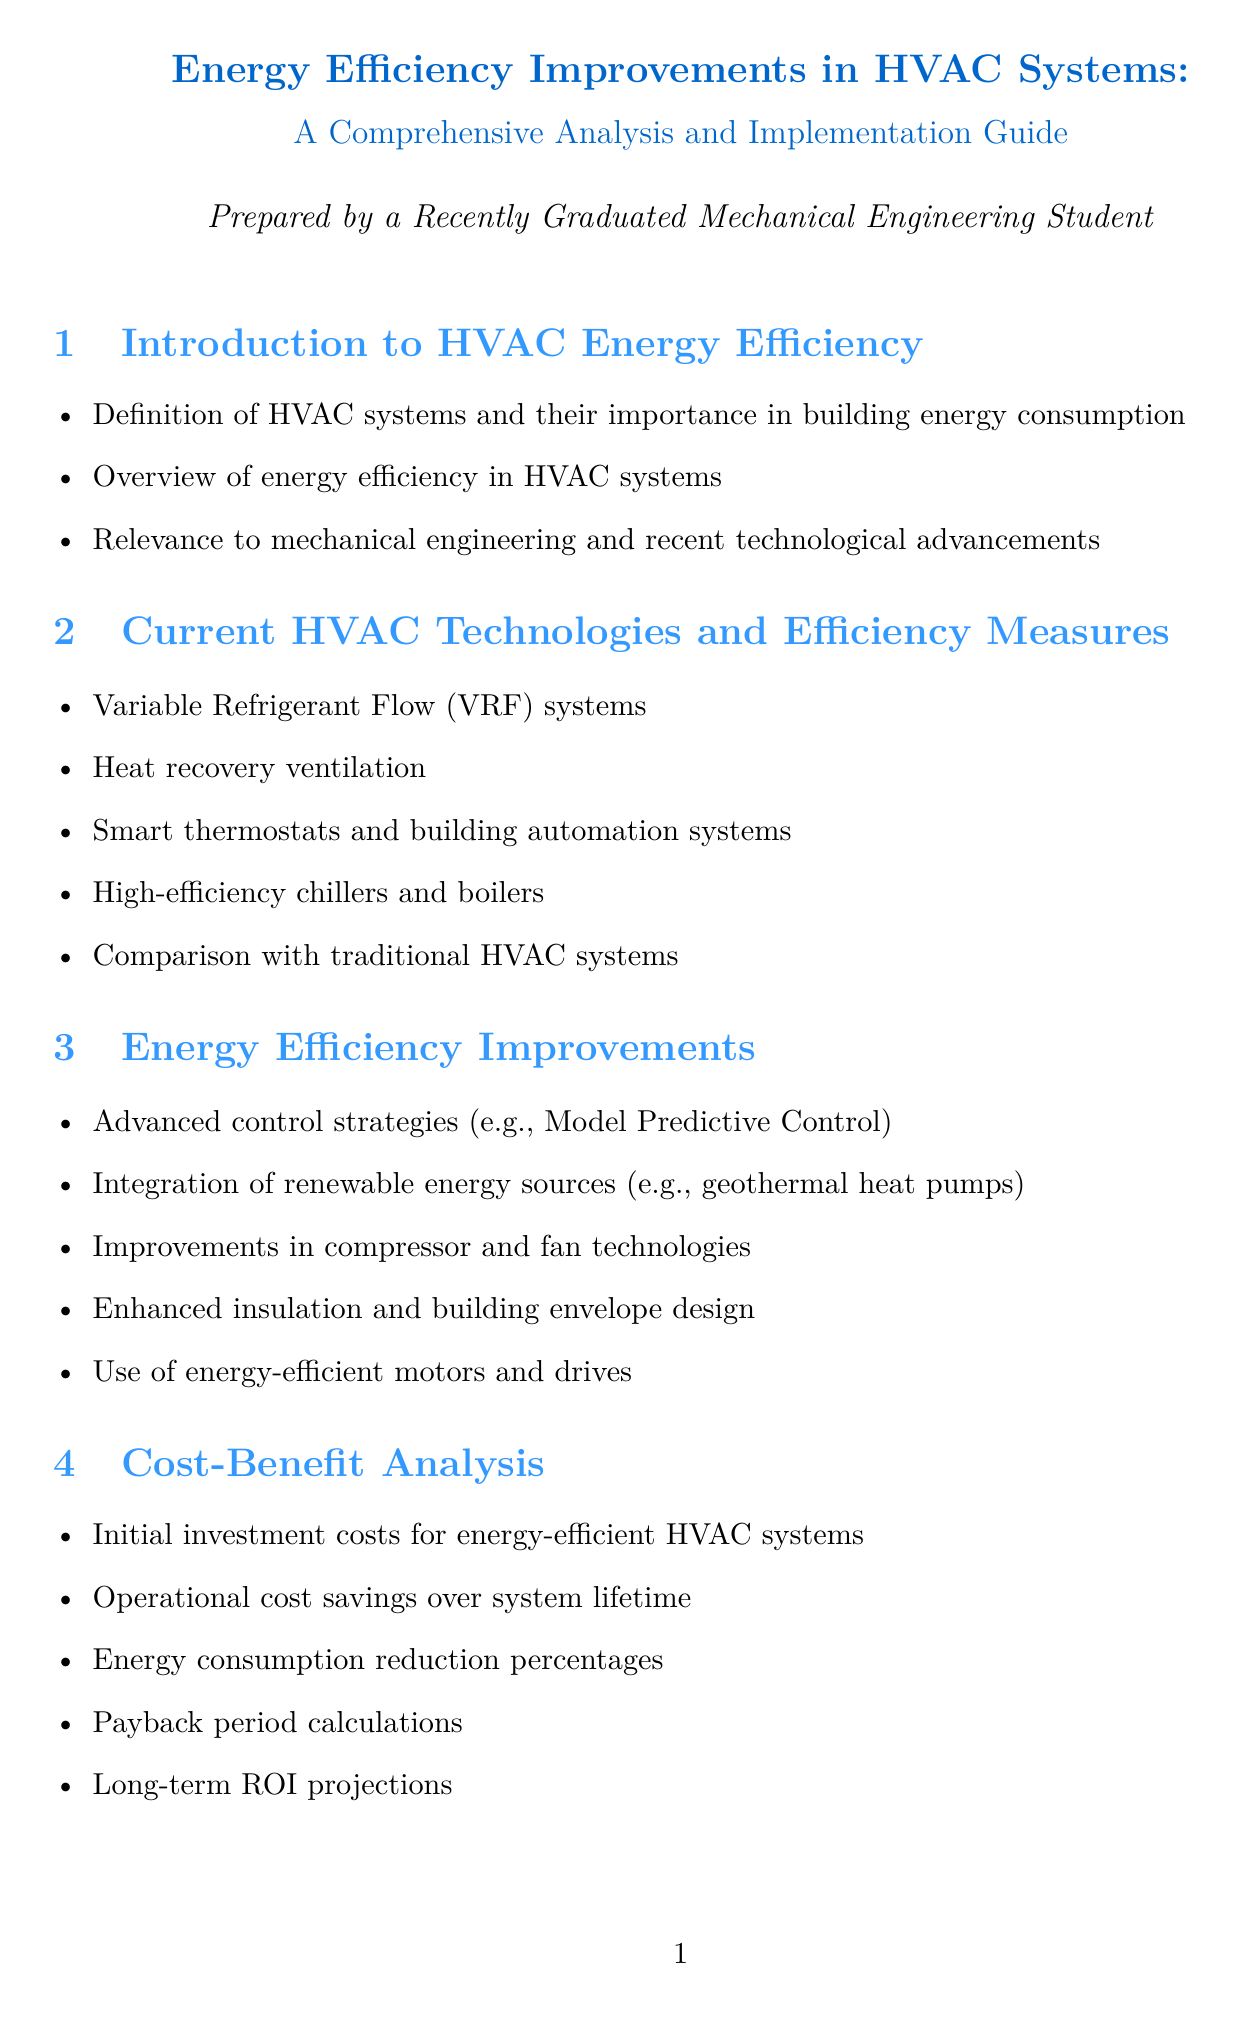What are Variable Refrigerant Flow systems? Variable Refrigerant Flow systems are a current HVAC technology included in the section discussing efficiency measures.
Answer: Variable Refrigerant Flow (VRF) systems What percentage of energy savings did Siemens Headquarters achieve? The specific case study of Siemens Headquarters highlights significant energy savings achieved through a geothermal heat pump.
Answer: 90% What are two examples of advanced control strategies mentioned? Advanced control strategies are discussed in the section on energy efficiency improvements, which includes varied techniques.
Answer: Model Predictive Control What is the initial focus of the report? The report's introduction covers the definition of HVAC systems and emphasizes their importance in energy consumption.
Answer: Introduction to HVAC Energy Efficiency Which organization sets the ASHRAE 90.1 energy standard? The regulatory landscape section of the report specifies standards that govern building energy efficiency, including ones from notable organizations.
Answer: ASHRAE What is one future trend in HVAC mentioned? The future trends section offers insights into innovations that are shaping upcoming HVAC technologies, providing an understanding of forward-looking developments.
Answer: Integration of AI and machine learning in HVAC control What is a key consideration when retrofitting HVAC systems? Implementation strategies provide insight regarding the considerations necessary when upgrading existing systems.
Answer: Retrofit vs. new installation considerations What is the payback period related to? The cost-benefit analysis section contains details on financial aspects, particularly relating to investment and return on energy-efficient HVAC systems.
Answer: Payback period calculations 